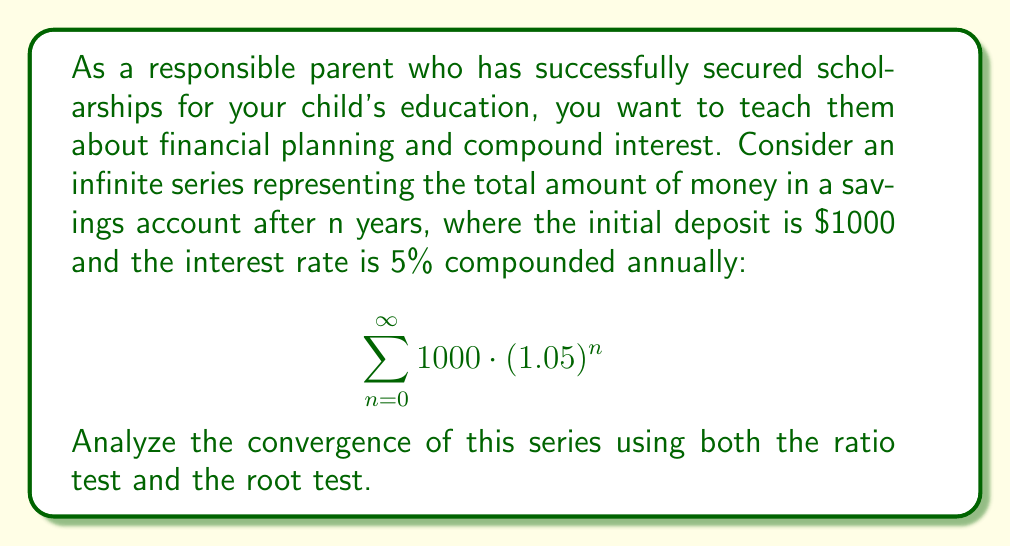Help me with this question. Let's analyze the convergence of this series using both the ratio test and the root test.

1. Ratio Test:
Let $a_n = 1000 \cdot (1.05)^n$

$$\lim_{n \to \infty} \left|\frac{a_{n+1}}{a_n}\right| = \lim_{n \to \infty} \left|\frac{1000 \cdot (1.05)^{n+1}}{1000 \cdot (1.05)^n}\right|$$

$$= \lim_{n \to \infty} \left|(1.05)^{n+1-n}\right| = \lim_{n \to \infty} |1.05| = 1.05$$

Since the limit is greater than 1, the ratio test concludes that the series diverges.

2. Root Test:
$$\lim_{n \to \infty} \sqrt[n]{|a_n|} = \lim_{n \to \infty} \sqrt[n]{|1000 \cdot (1.05)^n|}$$

$$= \lim_{n \to \infty} \sqrt[n]{1000} \cdot \sqrt[n]{(1.05)^n}$$

$$= 1 \cdot \lim_{n \to \infty} (1.05) = 1.05$$

Since the limit is greater than 1, the root test also concludes that the series diverges.

Both tests yield the same result, confirming that the series diverges. This makes sense financially, as the amount of money in the account will continue to grow without bound over time due to compound interest.
Answer: The series diverges according to both the ratio test and the root test, as both tests yield a value of 1.05, which is greater than 1. 